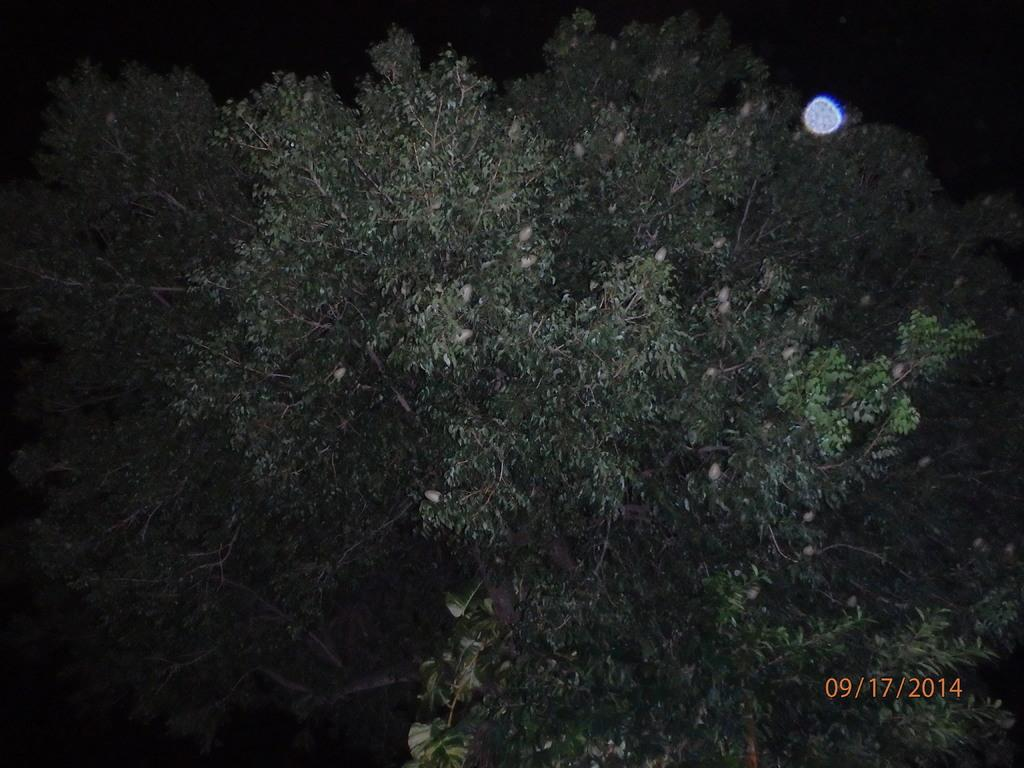What type of natural elements can be seen in the image? There are trees in the image. What celestial body is visible at the top of the image? The moon is visible at the top of the image. What is the color of the background in the image? The background of the image is black in color. Can you find the receipt for the vacation in the image? There is no receipt or mention of a vacation in the image. Are there any matches visible in the image? There are no matches present in the image. 